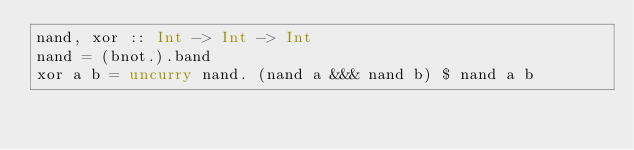<code> <loc_0><loc_0><loc_500><loc_500><_Haskell_>nand, xor :: Int -> Int -> Int
nand = (bnot.).band
xor a b = uncurry nand. (nand a &&& nand b) $ nand a b
</code> 